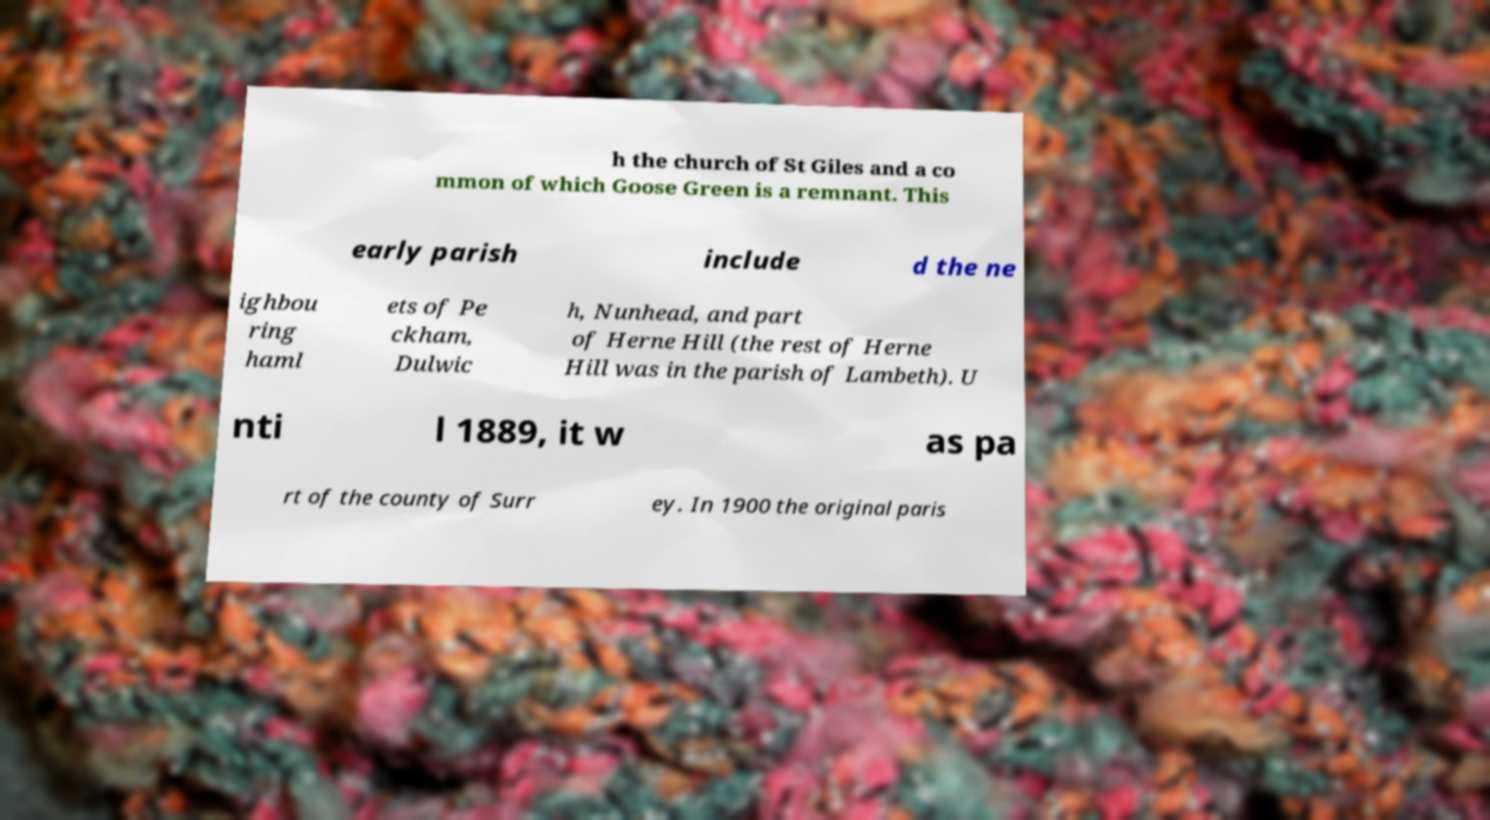Please read and relay the text visible in this image. What does it say? h the church of St Giles and a co mmon of which Goose Green is a remnant. This early parish include d the ne ighbou ring haml ets of Pe ckham, Dulwic h, Nunhead, and part of Herne Hill (the rest of Herne Hill was in the parish of Lambeth). U nti l 1889, it w as pa rt of the county of Surr ey. In 1900 the original paris 